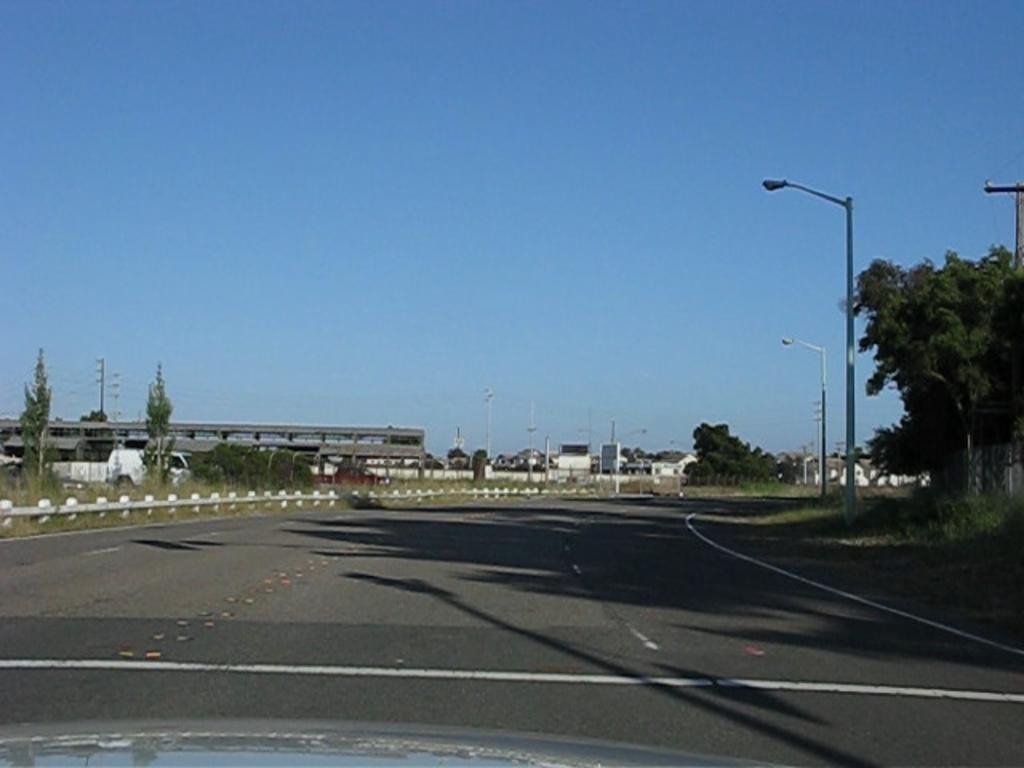What type of vegetation can be seen in the image? There are trees and plants in the image. What structures are present in the image? There are poles, lights, houses, and a vehicle in the image. What type of pathway is visible in the image? There is a road in the image. What can be seen in the background of the image? The sky is visible in the background of the image. What type of bat is sitting on the throne in the image? There is no bat or throne present in the image. What word is written on the vehicle in the image? There is no text visible on the vehicle in the image. 